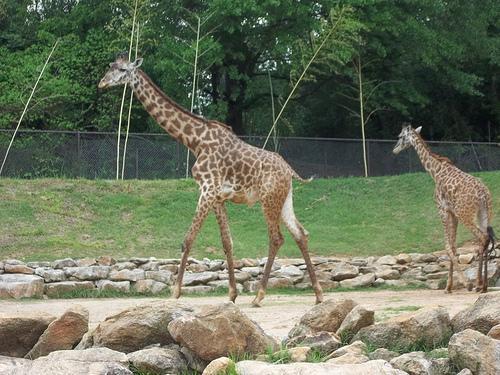How many black giraffes are there?
Give a very brief answer. 0. 